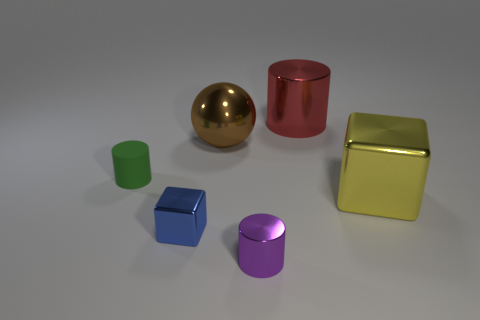Subtract all small cylinders. How many cylinders are left? 1 Subtract all red cylinders. How many cylinders are left? 2 Subtract all blocks. How many objects are left? 4 Subtract 2 blocks. How many blocks are left? 0 Add 3 big yellow shiny blocks. How many big yellow shiny blocks exist? 4 Add 2 purple metal cylinders. How many objects exist? 8 Subtract 0 red spheres. How many objects are left? 6 Subtract all brown cubes. Subtract all brown cylinders. How many cubes are left? 2 Subtract all green cylinders. How many blue cubes are left? 1 Subtract all gray cylinders. Subtract all large metal balls. How many objects are left? 5 